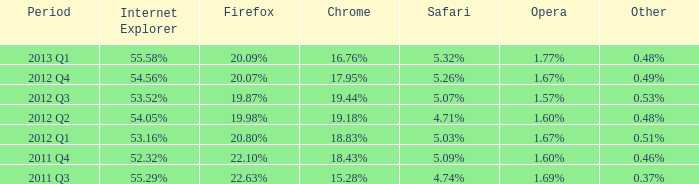What period has 53.52% as the internet explorer? 2012 Q3. 